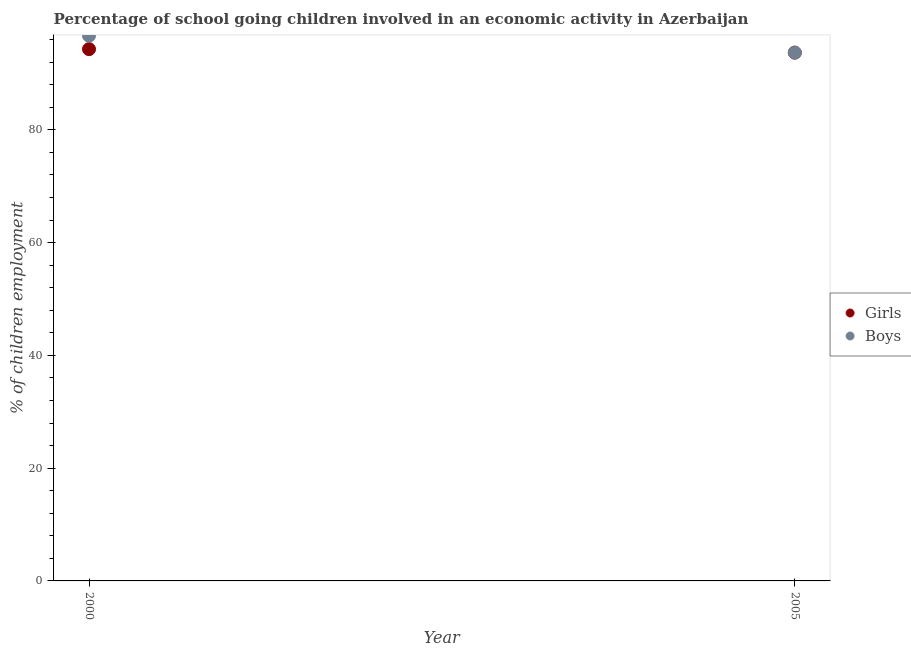How many different coloured dotlines are there?
Make the answer very short. 2. What is the percentage of school going boys in 2000?
Offer a very short reply. 96.7. Across all years, what is the maximum percentage of school going girls?
Ensure brevity in your answer.  94.32. Across all years, what is the minimum percentage of school going girls?
Your answer should be compact. 93.7. What is the total percentage of school going girls in the graph?
Ensure brevity in your answer.  188.02. What is the difference between the percentage of school going boys in 2000 and that in 2005?
Offer a very short reply. 3. What is the difference between the percentage of school going boys in 2000 and the percentage of school going girls in 2005?
Ensure brevity in your answer.  3. What is the average percentage of school going girls per year?
Provide a short and direct response. 94.01. What is the ratio of the percentage of school going boys in 2000 to that in 2005?
Make the answer very short. 1.03. Is the percentage of school going boys in 2000 less than that in 2005?
Keep it short and to the point. No. Does the percentage of school going boys monotonically increase over the years?
Your answer should be very brief. No. Is the percentage of school going girls strictly greater than the percentage of school going boys over the years?
Provide a succinct answer. No. Is the percentage of school going boys strictly less than the percentage of school going girls over the years?
Keep it short and to the point. No. Are the values on the major ticks of Y-axis written in scientific E-notation?
Ensure brevity in your answer.  No. Does the graph contain grids?
Make the answer very short. No. How many legend labels are there?
Your response must be concise. 2. What is the title of the graph?
Your answer should be compact. Percentage of school going children involved in an economic activity in Azerbaijan. What is the label or title of the X-axis?
Ensure brevity in your answer.  Year. What is the label or title of the Y-axis?
Ensure brevity in your answer.  % of children employment. What is the % of children employment in Girls in 2000?
Offer a very short reply. 94.32. What is the % of children employment of Boys in 2000?
Offer a very short reply. 96.7. What is the % of children employment of Girls in 2005?
Provide a short and direct response. 93.7. What is the % of children employment in Boys in 2005?
Provide a succinct answer. 93.7. Across all years, what is the maximum % of children employment in Girls?
Your response must be concise. 94.32. Across all years, what is the maximum % of children employment of Boys?
Offer a terse response. 96.7. Across all years, what is the minimum % of children employment in Girls?
Make the answer very short. 93.7. Across all years, what is the minimum % of children employment of Boys?
Offer a terse response. 93.7. What is the total % of children employment in Girls in the graph?
Provide a succinct answer. 188.02. What is the total % of children employment in Boys in the graph?
Make the answer very short. 190.4. What is the difference between the % of children employment of Girls in 2000 and that in 2005?
Offer a terse response. 0.62. What is the difference between the % of children employment in Boys in 2000 and that in 2005?
Your answer should be very brief. 3. What is the difference between the % of children employment in Girls in 2000 and the % of children employment in Boys in 2005?
Provide a short and direct response. 0.62. What is the average % of children employment of Girls per year?
Make the answer very short. 94.01. What is the average % of children employment of Boys per year?
Offer a very short reply. 95.2. In the year 2000, what is the difference between the % of children employment in Girls and % of children employment in Boys?
Provide a succinct answer. -2.38. In the year 2005, what is the difference between the % of children employment in Girls and % of children employment in Boys?
Offer a terse response. 0. What is the ratio of the % of children employment in Girls in 2000 to that in 2005?
Make the answer very short. 1.01. What is the ratio of the % of children employment of Boys in 2000 to that in 2005?
Provide a succinct answer. 1.03. What is the difference between the highest and the second highest % of children employment of Girls?
Keep it short and to the point. 0.62. What is the difference between the highest and the second highest % of children employment of Boys?
Provide a short and direct response. 3. What is the difference between the highest and the lowest % of children employment of Girls?
Your answer should be compact. 0.62. What is the difference between the highest and the lowest % of children employment of Boys?
Offer a very short reply. 3. 